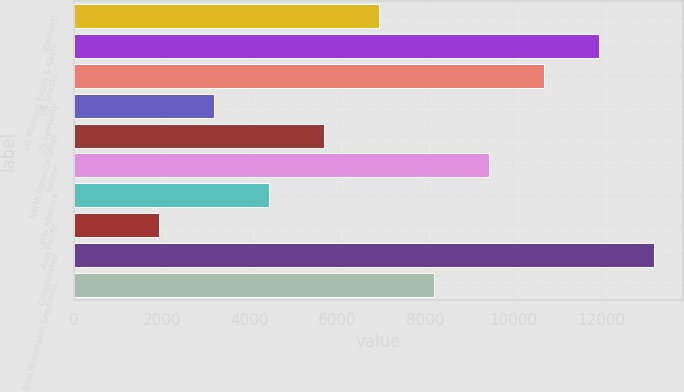<chart> <loc_0><loc_0><loc_500><loc_500><bar_chart><fcel>(millions)<fcel>US Morning Foods & Kashi<fcel>US Snacks<fcel>US Specialty<fcel>North America Other<fcel>Europe<fcel>Latin America<fcel>Asia Pacific<fcel>Consolidated<fcel>Total Reportable Segments<nl><fcel>6941<fcel>11946.6<fcel>10695.2<fcel>3186.8<fcel>5689.6<fcel>9443.8<fcel>4438.2<fcel>1935.4<fcel>13198<fcel>8192.4<nl></chart> 